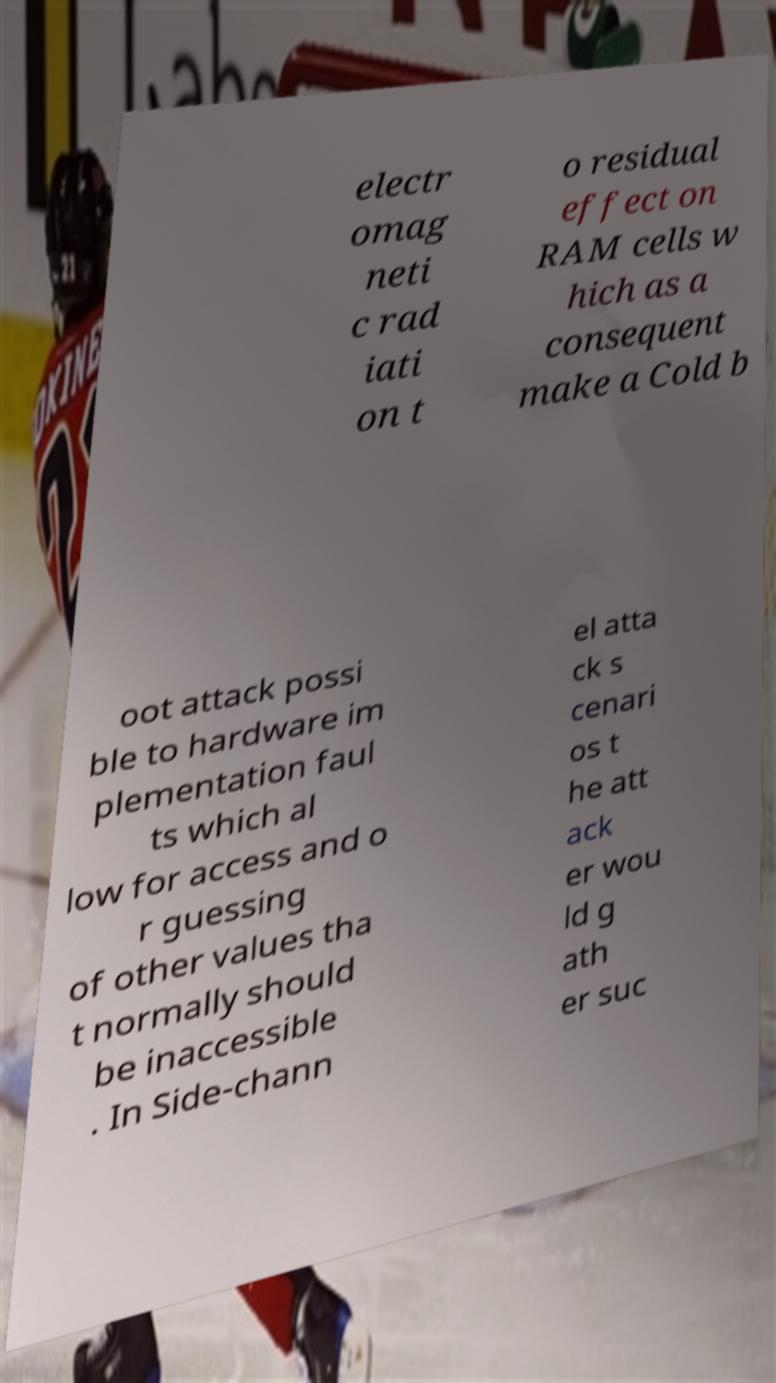For documentation purposes, I need the text within this image transcribed. Could you provide that? electr omag neti c rad iati on t o residual effect on RAM cells w hich as a consequent make a Cold b oot attack possi ble to hardware im plementation faul ts which al low for access and o r guessing of other values tha t normally should be inaccessible . In Side-chann el atta ck s cenari os t he att ack er wou ld g ath er suc 